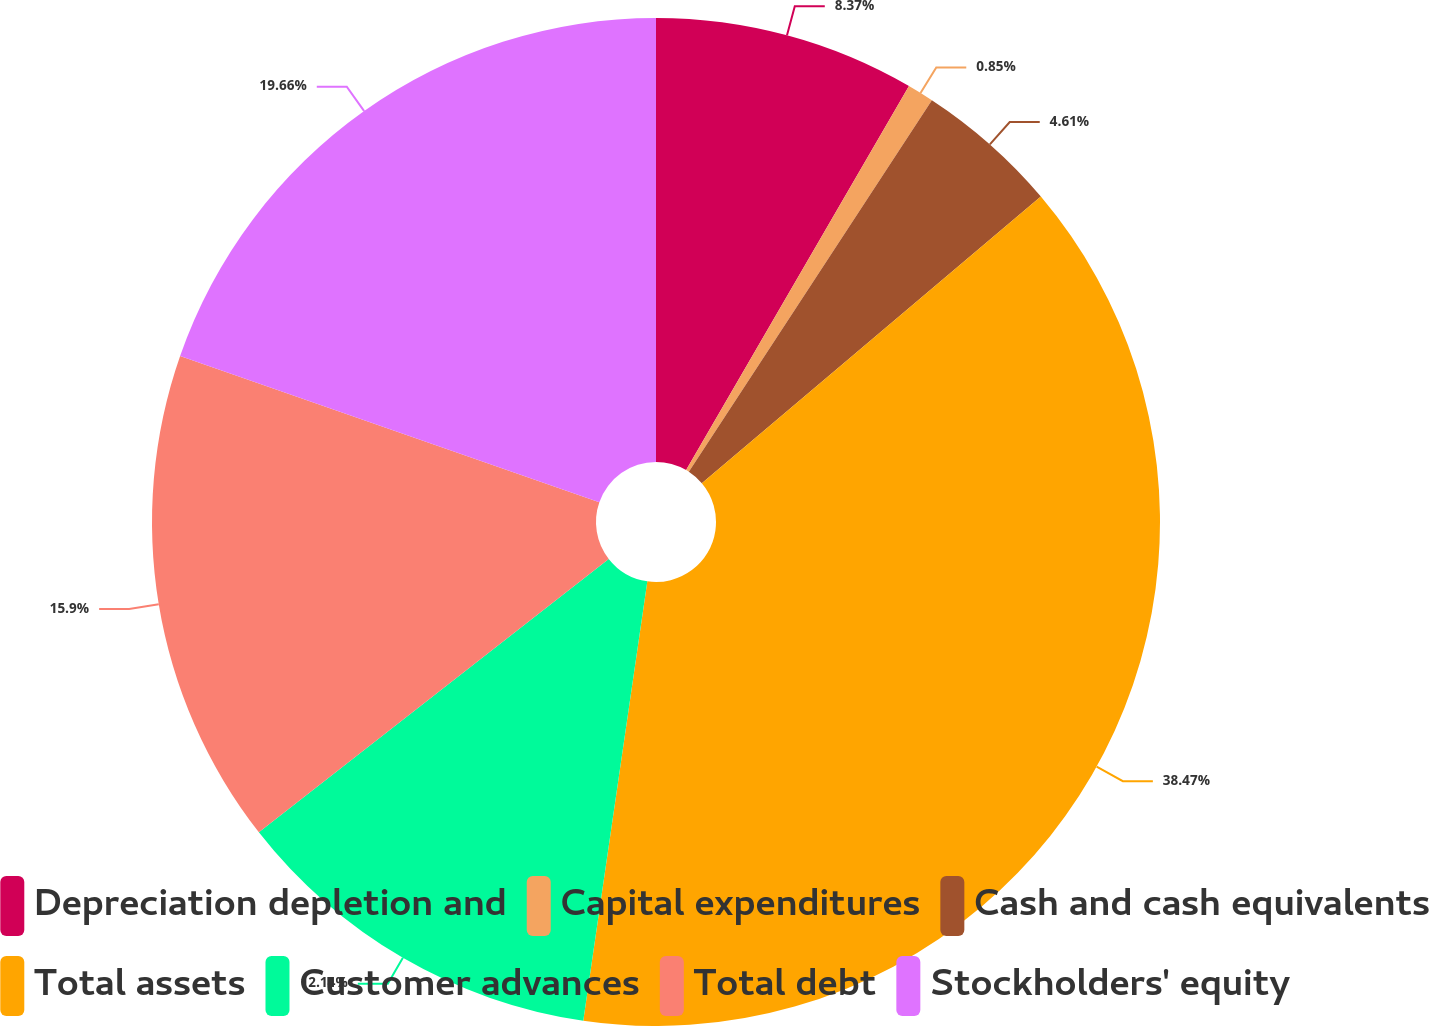<chart> <loc_0><loc_0><loc_500><loc_500><pie_chart><fcel>Depreciation depletion and<fcel>Capital expenditures<fcel>Cash and cash equivalents<fcel>Total assets<fcel>Customer advances<fcel>Total debt<fcel>Stockholders' equity<nl><fcel>8.37%<fcel>0.85%<fcel>4.61%<fcel>38.48%<fcel>12.14%<fcel>15.9%<fcel>19.66%<nl></chart> 